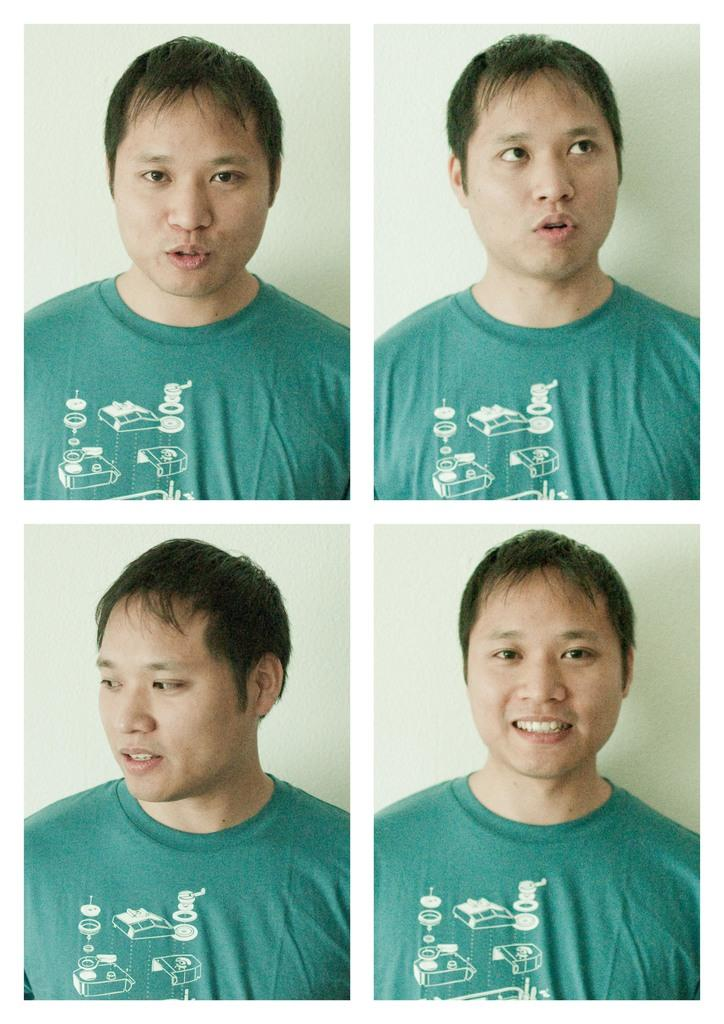What is the main subject of the image? There is a person in the image. What is the person wearing? The person is wearing a t-shirt. What is the person's facial expression? The person is smiling. What is the color of the background in the image? The background of the image is white. How was the image created? The image is edited and created as a collage. How many chairs are visible in the image? There are no chairs present in the image. What type of hydrant is visible in the image? There is no hydrant present in the image. 